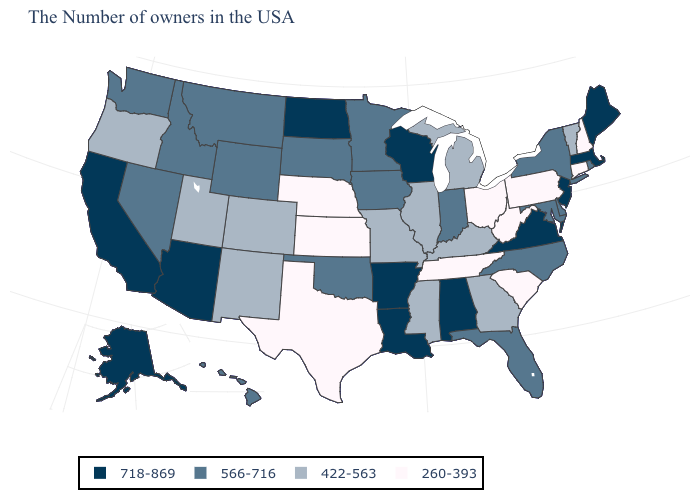Name the states that have a value in the range 566-716?
Write a very short answer. Rhode Island, New York, Delaware, Maryland, North Carolina, Florida, Indiana, Minnesota, Iowa, Oklahoma, South Dakota, Wyoming, Montana, Idaho, Nevada, Washington, Hawaii. What is the value of Iowa?
Quick response, please. 566-716. What is the value of New Hampshire?
Keep it brief. 260-393. Name the states that have a value in the range 718-869?
Concise answer only. Maine, Massachusetts, New Jersey, Virginia, Alabama, Wisconsin, Louisiana, Arkansas, North Dakota, Arizona, California, Alaska. Among the states that border Connecticut , does Rhode Island have the lowest value?
Quick response, please. Yes. What is the highest value in states that border Kansas?
Be succinct. 566-716. Name the states that have a value in the range 718-869?
Quick response, please. Maine, Massachusetts, New Jersey, Virginia, Alabama, Wisconsin, Louisiana, Arkansas, North Dakota, Arizona, California, Alaska. Among the states that border Rhode Island , which have the highest value?
Answer briefly. Massachusetts. What is the lowest value in the MidWest?
Be succinct. 260-393. Name the states that have a value in the range 260-393?
Be succinct. New Hampshire, Connecticut, Pennsylvania, South Carolina, West Virginia, Ohio, Tennessee, Kansas, Nebraska, Texas. Does Alaska have the same value as California?
Short answer required. Yes. How many symbols are there in the legend?
Concise answer only. 4. What is the value of Tennessee?
Be succinct. 260-393. Name the states that have a value in the range 422-563?
Be succinct. Vermont, Georgia, Michigan, Kentucky, Illinois, Mississippi, Missouri, Colorado, New Mexico, Utah, Oregon. What is the value of Oklahoma?
Short answer required. 566-716. 